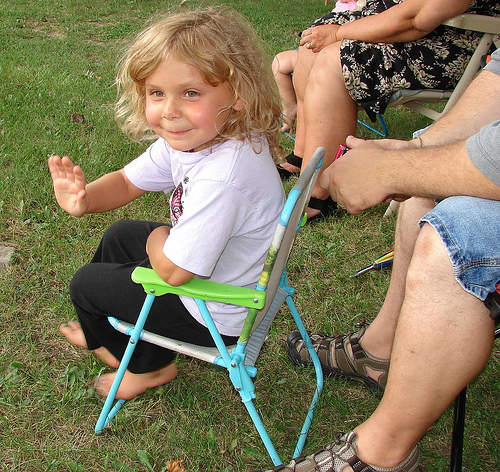<image>
Can you confirm if the child sitting is on the grass? No. The child sitting is not positioned on the grass. They may be near each other, but the child sitting is not supported by or resting on top of the grass. Is the chair to the right of the shoe? Yes. From this viewpoint, the chair is positioned to the right side relative to the shoe. 